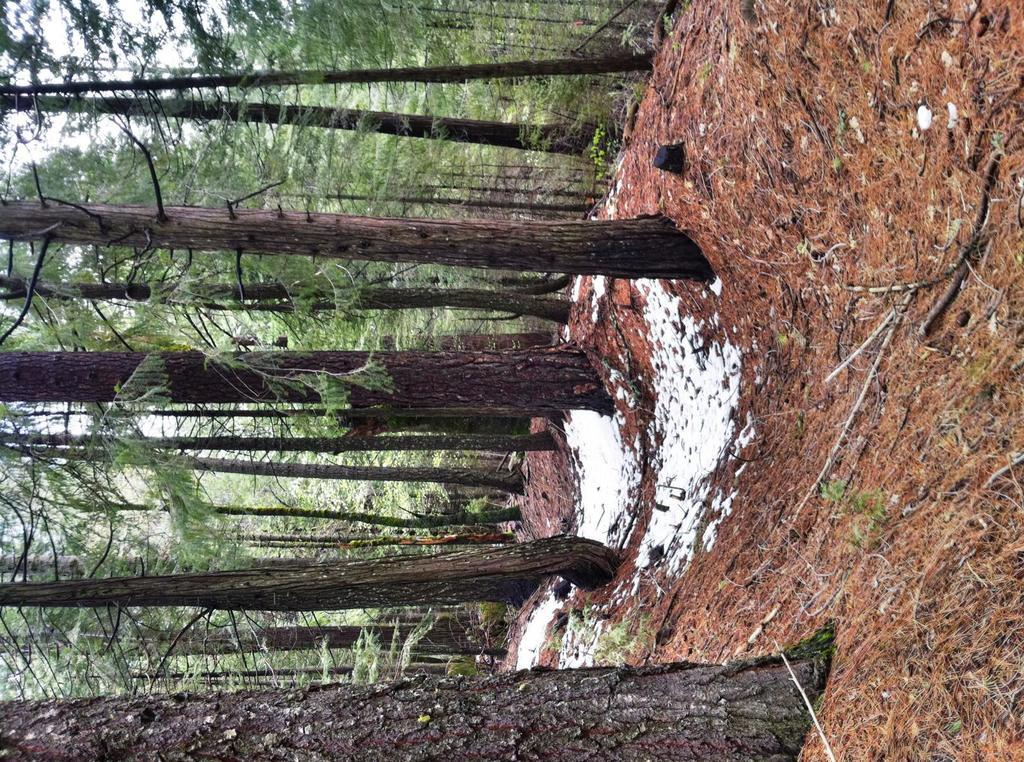What can be seen in the background of the image? The sky is visible in the image. What type of vegetation is present in the image? There are trees in the image. What is on the ground in the image? Shredded leaves and twigs are present on the ground in the image. What type of feeling is depicted in the image? There is no specific feeling depicted in the image; it is a scene of the sky, trees, and the ground. How many planes can be seen in the image? There are no planes present in the image. 